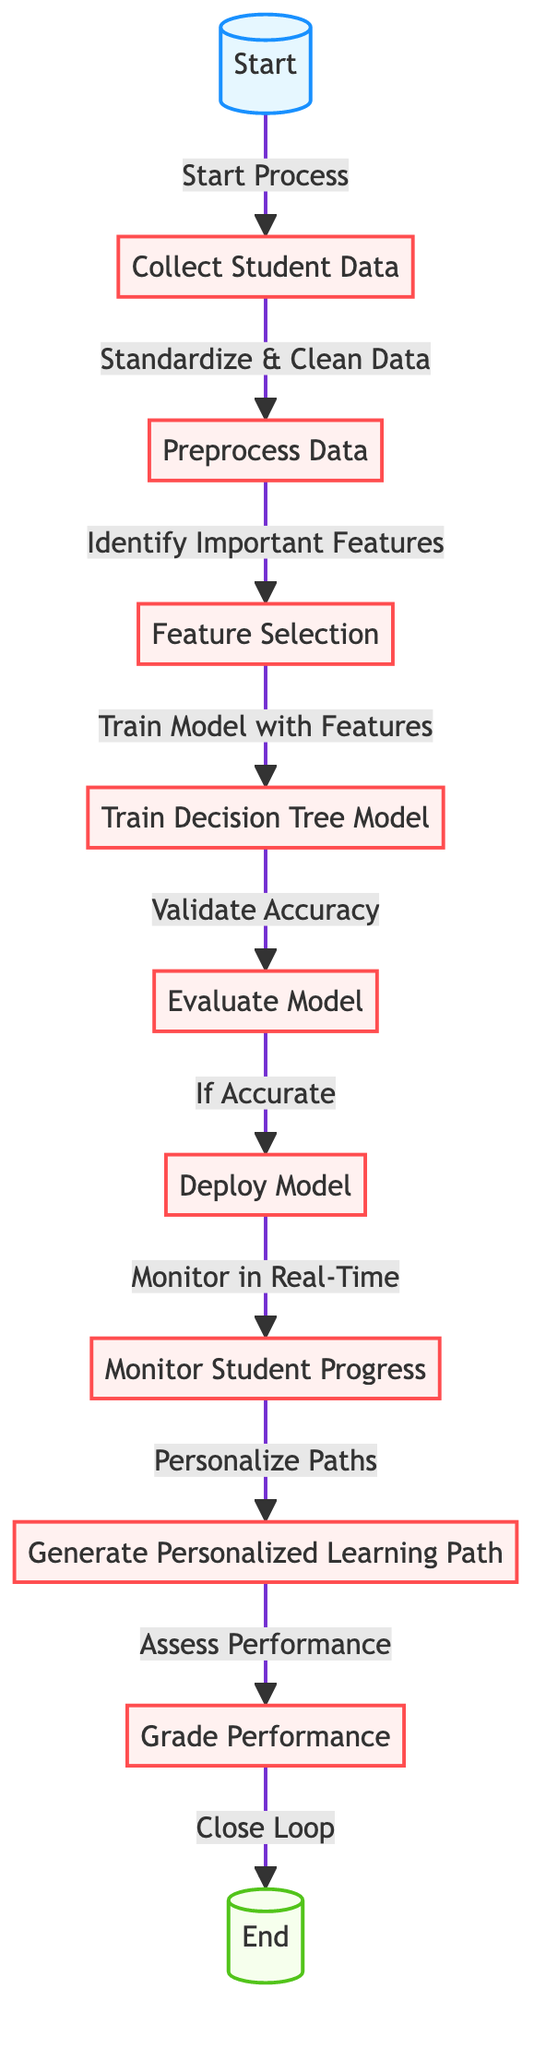What is the first step in the diagram? The diagram starts with the node labeled "Start," which initiates the flow.
Answer: Start How many processes are involved before generating a personalized learning path? There are seven processes listed in the diagram before generating the personalized learning path.
Answer: Seven What action follows evaluating the model? After evaluating the model, the next action is to deploy the model.
Answer: Deploy Model What is done after monitoring student progress? Following monitoring student progress, the next action is to generate personalized learning paths.
Answer: Generate Personalized Learning Path How many total nodes are in the diagram? The diagram contains a total of eleven nodes, including the start and end nodes.
Answer: Eleven What feature selection follows collecting student data? After collecting student data, the feature selection process follows.
Answer: Feature Selection What happens if the model is considered accurate? If the model is accurate, the model is deployed for further monitoring of student progress.
Answer: Deploy Model Which node comes directly before grading performance? The node that comes directly before grading performance is "Generate Personalized Learning Path."
Answer: Generate Personalized Learning Path How does the diagram close the loop after performance assessment? The diagram indicates closing the loop immediately after grading performance, leading to the end of the process.
Answer: Close Loop 